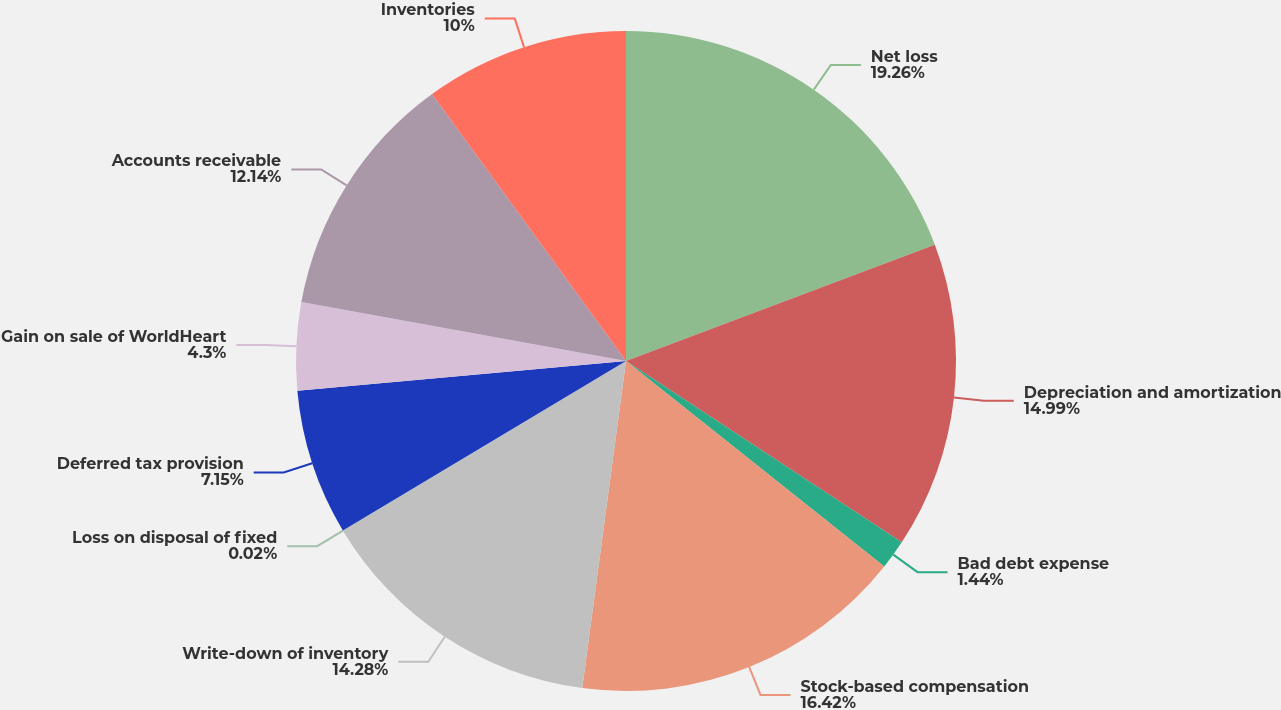Convert chart. <chart><loc_0><loc_0><loc_500><loc_500><pie_chart><fcel>Net loss<fcel>Depreciation and amortization<fcel>Bad debt expense<fcel>Stock-based compensation<fcel>Write-down of inventory<fcel>Loss on disposal of fixed<fcel>Deferred tax provision<fcel>Gain on sale of WorldHeart<fcel>Accounts receivable<fcel>Inventories<nl><fcel>19.27%<fcel>14.99%<fcel>1.44%<fcel>16.42%<fcel>14.28%<fcel>0.02%<fcel>7.15%<fcel>4.3%<fcel>12.14%<fcel>10.0%<nl></chart> 